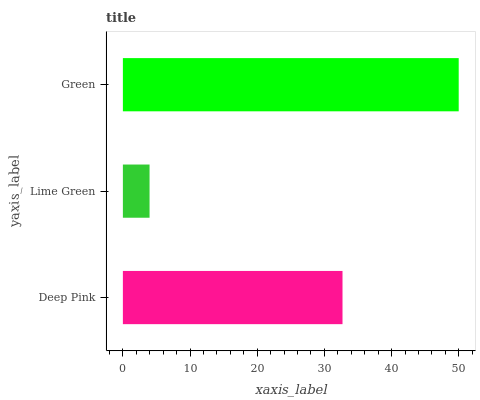Is Lime Green the minimum?
Answer yes or no. Yes. Is Green the maximum?
Answer yes or no. Yes. Is Green the minimum?
Answer yes or no. No. Is Lime Green the maximum?
Answer yes or no. No. Is Green greater than Lime Green?
Answer yes or no. Yes. Is Lime Green less than Green?
Answer yes or no. Yes. Is Lime Green greater than Green?
Answer yes or no. No. Is Green less than Lime Green?
Answer yes or no. No. Is Deep Pink the high median?
Answer yes or no. Yes. Is Deep Pink the low median?
Answer yes or no. Yes. Is Lime Green the high median?
Answer yes or no. No. Is Lime Green the low median?
Answer yes or no. No. 